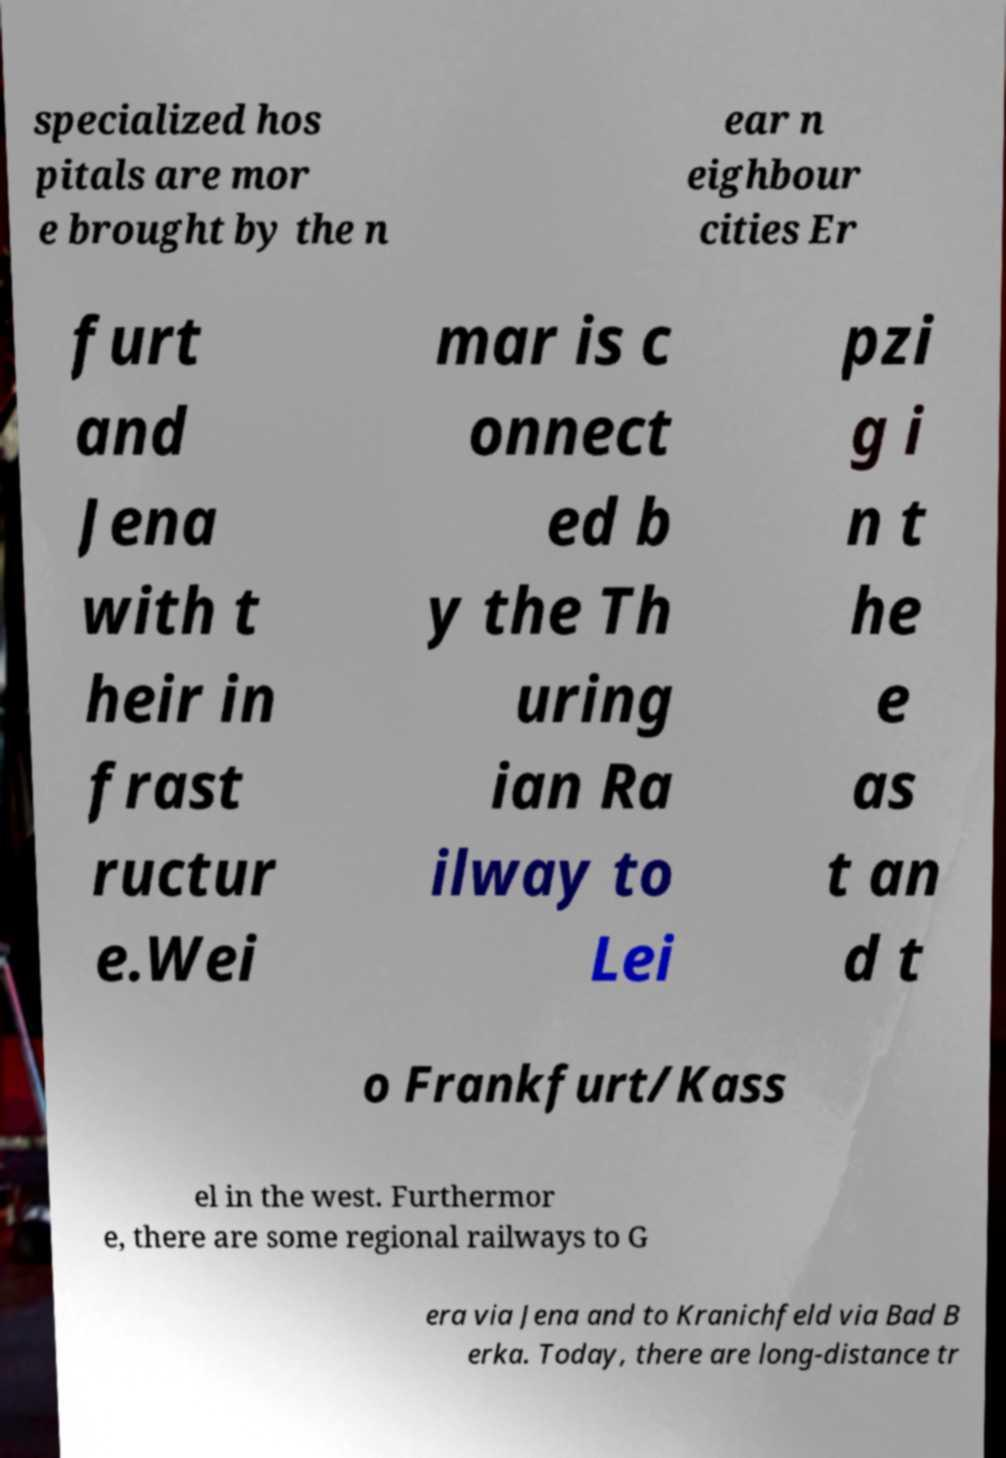Please identify and transcribe the text found in this image. specialized hos pitals are mor e brought by the n ear n eighbour cities Er furt and Jena with t heir in frast ructur e.Wei mar is c onnect ed b y the Th uring ian Ra ilway to Lei pzi g i n t he e as t an d t o Frankfurt/Kass el in the west. Furthermor e, there are some regional railways to G era via Jena and to Kranichfeld via Bad B erka. Today, there are long-distance tr 